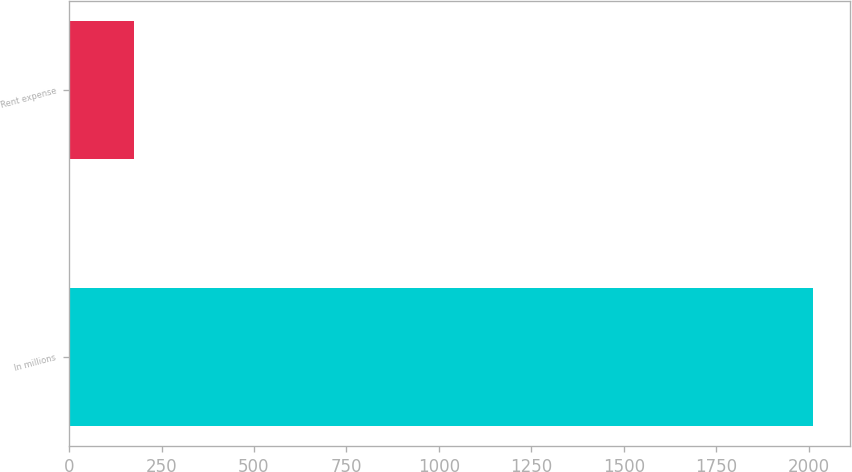Convert chart. <chart><loc_0><loc_0><loc_500><loc_500><bar_chart><fcel>In millions<fcel>Rent expense<nl><fcel>2012<fcel>176<nl></chart> 